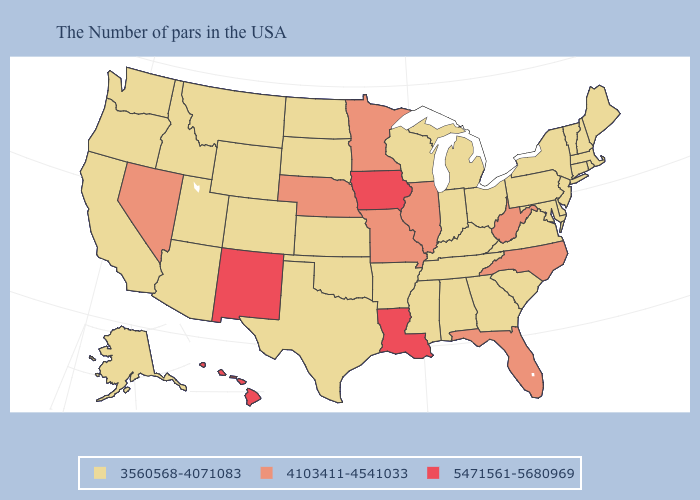What is the lowest value in states that border Idaho?
Short answer required. 3560568-4071083. Name the states that have a value in the range 5471561-5680969?
Keep it brief. Louisiana, Iowa, New Mexico, Hawaii. Name the states that have a value in the range 3560568-4071083?
Give a very brief answer. Maine, Massachusetts, Rhode Island, New Hampshire, Vermont, Connecticut, New York, New Jersey, Delaware, Maryland, Pennsylvania, Virginia, South Carolina, Ohio, Georgia, Michigan, Kentucky, Indiana, Alabama, Tennessee, Wisconsin, Mississippi, Arkansas, Kansas, Oklahoma, Texas, South Dakota, North Dakota, Wyoming, Colorado, Utah, Montana, Arizona, Idaho, California, Washington, Oregon, Alaska. What is the lowest value in the West?
Answer briefly. 3560568-4071083. Does North Dakota have the lowest value in the USA?
Short answer required. Yes. What is the value of North Carolina?
Be succinct. 4103411-4541033. Name the states that have a value in the range 3560568-4071083?
Write a very short answer. Maine, Massachusetts, Rhode Island, New Hampshire, Vermont, Connecticut, New York, New Jersey, Delaware, Maryland, Pennsylvania, Virginia, South Carolina, Ohio, Georgia, Michigan, Kentucky, Indiana, Alabama, Tennessee, Wisconsin, Mississippi, Arkansas, Kansas, Oklahoma, Texas, South Dakota, North Dakota, Wyoming, Colorado, Utah, Montana, Arizona, Idaho, California, Washington, Oregon, Alaska. Which states have the lowest value in the USA?
Write a very short answer. Maine, Massachusetts, Rhode Island, New Hampshire, Vermont, Connecticut, New York, New Jersey, Delaware, Maryland, Pennsylvania, Virginia, South Carolina, Ohio, Georgia, Michigan, Kentucky, Indiana, Alabama, Tennessee, Wisconsin, Mississippi, Arkansas, Kansas, Oklahoma, Texas, South Dakota, North Dakota, Wyoming, Colorado, Utah, Montana, Arizona, Idaho, California, Washington, Oregon, Alaska. Does Hawaii have the highest value in the USA?
Be succinct. Yes. How many symbols are there in the legend?
Quick response, please. 3. Among the states that border Montana , which have the lowest value?
Be succinct. South Dakota, North Dakota, Wyoming, Idaho. Does Wisconsin have the same value as North Carolina?
Answer briefly. No. What is the lowest value in the Northeast?
Answer briefly. 3560568-4071083. Among the states that border New Hampshire , which have the lowest value?
Give a very brief answer. Maine, Massachusetts, Vermont. What is the value of Tennessee?
Give a very brief answer. 3560568-4071083. 